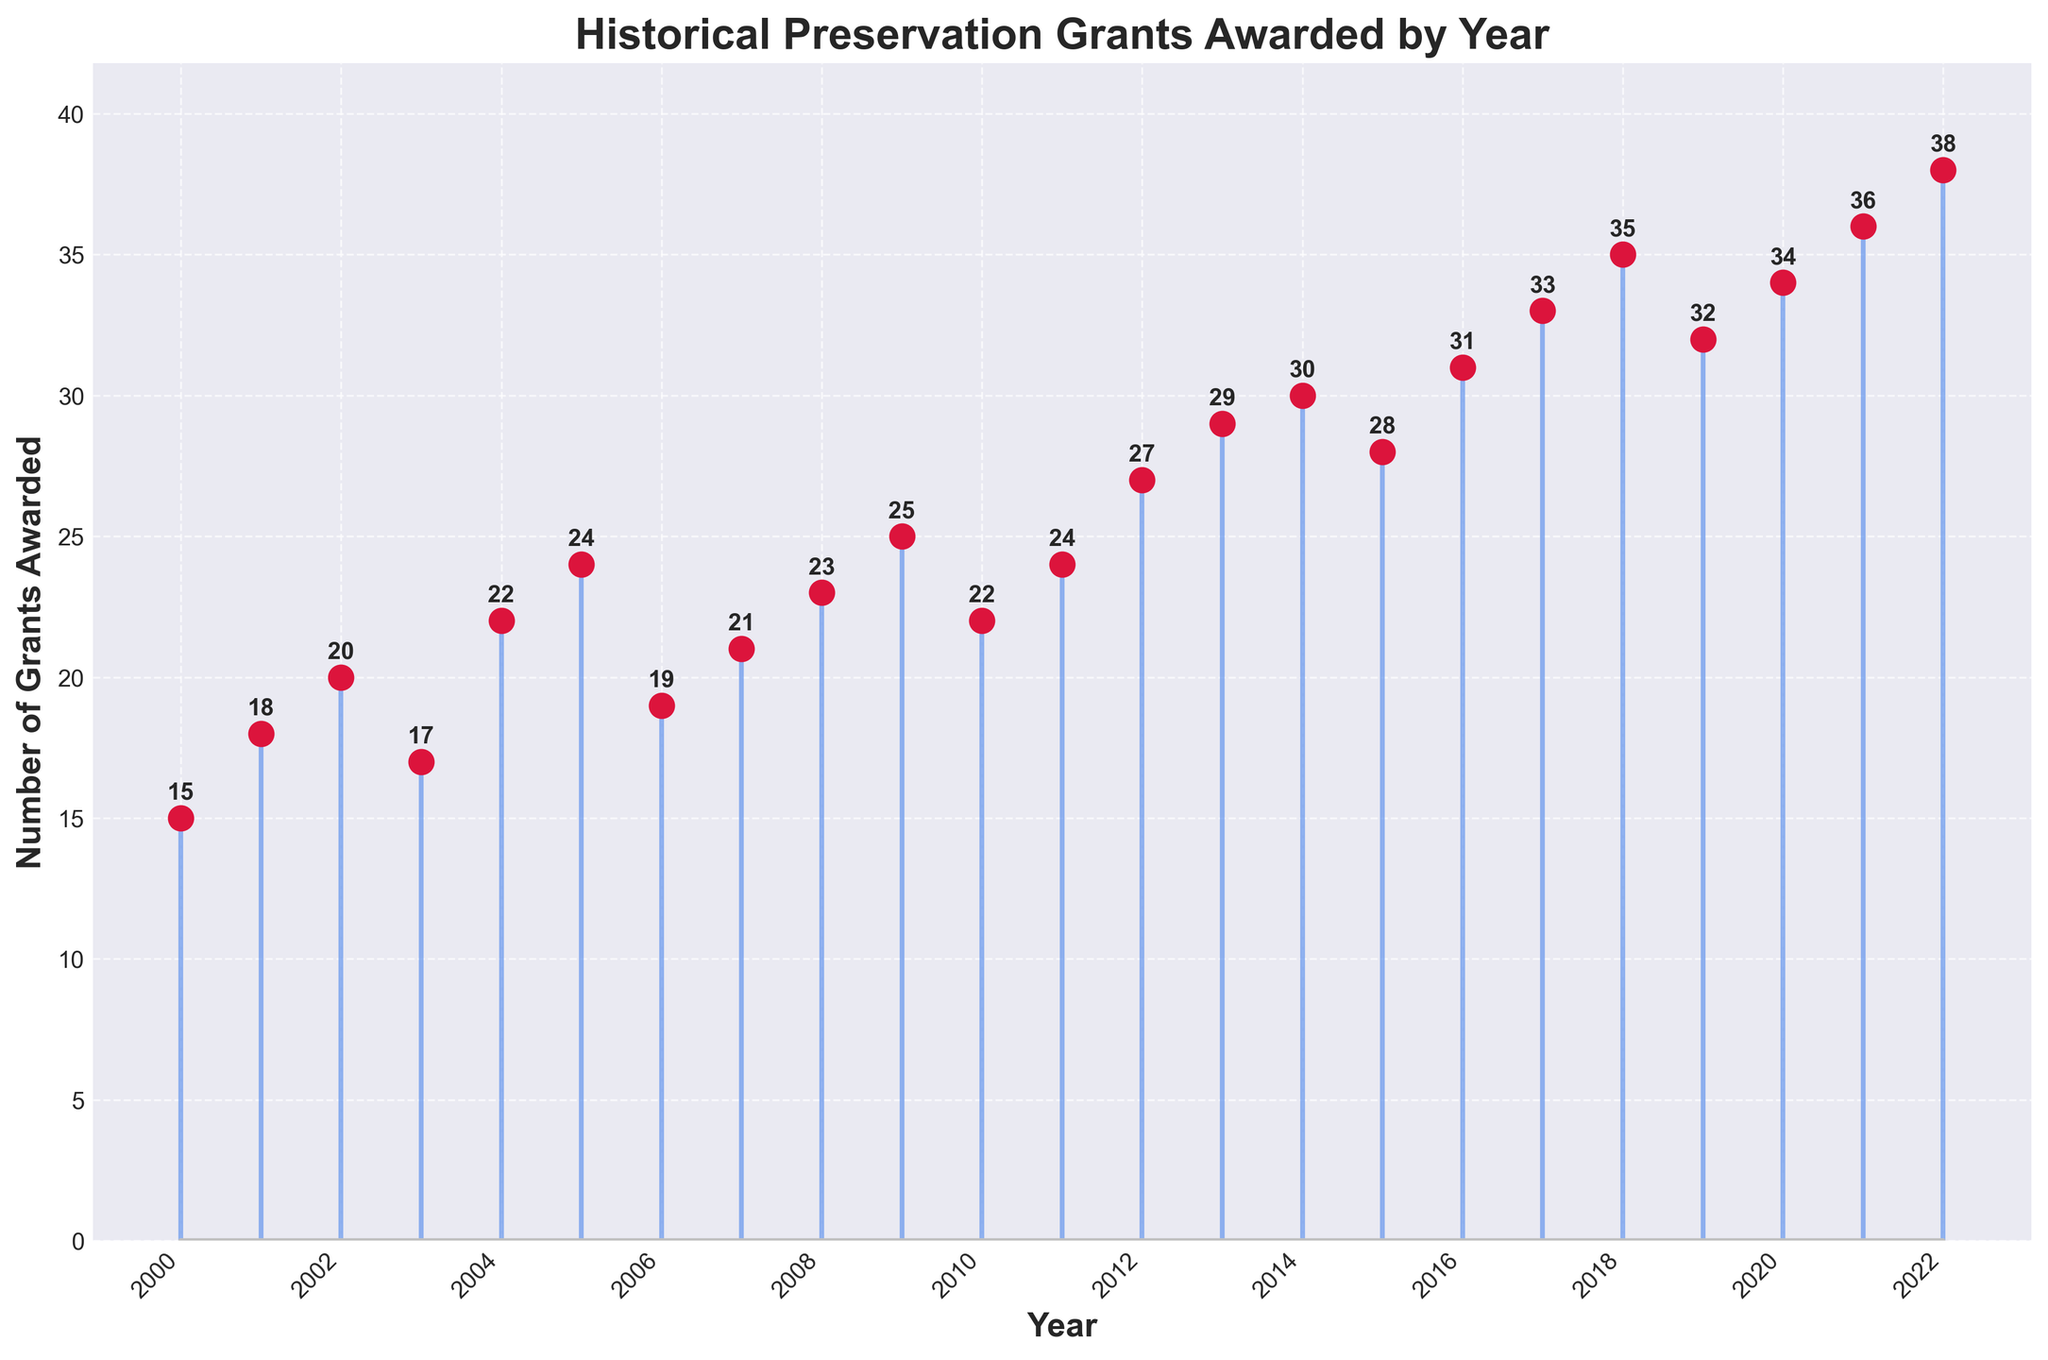How many grants were awarded in 2022? Reference the data label for the year 2022. It shows "38" grants awarded.
Answer: 38 What is the general trend in the number of grants awarded from 2000 to 2022? The overall trend appears to be an increase in the number of grants awarded over the years. Visualize the increasing height of stems from left to right.
Answer: Increasing Which year saw the most grants awarded, and how many were awarded that year? Look for the tallest stem and check its corresponding year and value. The year 2022 shows the highest value with 38 grants awarded.
Answer: 2022, 38 What was the average number of grants awarded per year between 2010 and 2015? Sum the values from 2010 to 2015 (22 + 24 + 27 + 29 + 30 + 28) and divide by 6 (number of years). Calculation: (22 + 24 + 27 + 29 + 30 + 28) / 6 = 26.67.
Answer: 26.67 In which year did the number of grants awarded first surpass 30? Check the stems for values exceeding 30 and note the first occurrence. The year 2014 shows 30 grants, but the first year to surpass 30 is 2016 with 31 grants.
Answer: 2016 How many more grants were awarded in 2021 compared to 2000? Subtract the number of grants awarded in 2000 from the number awarded in 2021. Calculation: 36 - 15 = 21.
Answer: 21 What is the median number of grants awarded from 2000 to 2022? Sort the values and find the middle one: 15, 17, 18, 19, 20, 21, 22, 22, 23, 24, 24, 25, 27, 28, 29, 30, 31, 32, 33, 34, 35, 36, 38. The median value is the middle element, which is 24.
Answer: 24 Which years had exactly 24 grants awarded, and how many such years are there? Identify the stems that reach the value of 24. The years 2005, 2011, and 2019 had 24 grants awarded. There are 3 such years.
Answer: 2005, 2011, 2019; 3 How did the number of grants change from 2008 to 2009? Subtract the number of grants in 2008 from the number in 2009. Calculation: 25 - 23 = 2. There was an increase of 2 grants.
Answer: Increased by 2 